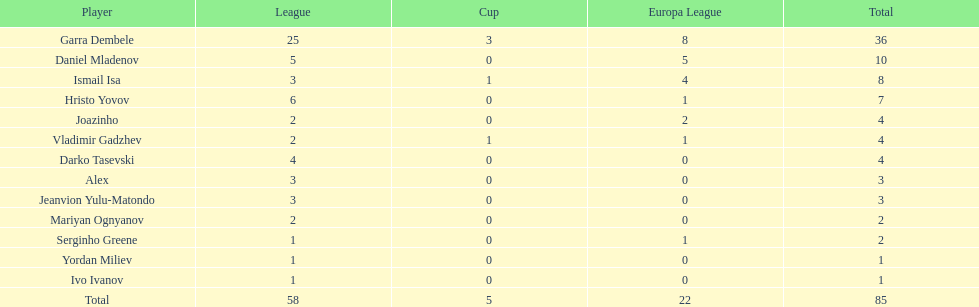Which players only scored one goal? Serginho Greene, Yordan Miliev, Ivo Ivanov. 